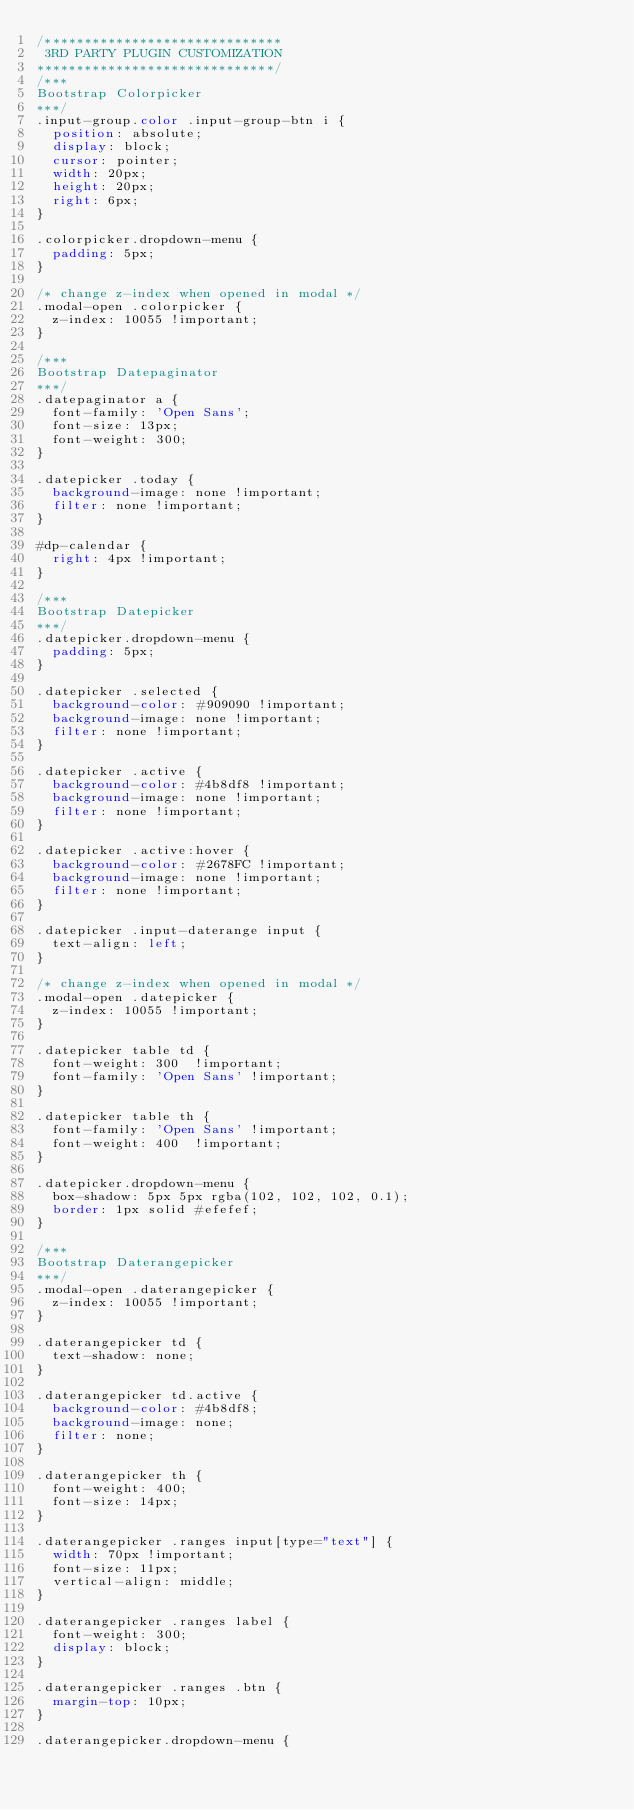Convert code to text. <code><loc_0><loc_0><loc_500><loc_500><_CSS_>/******************************
 3RD PARTY PLUGIN CUSTOMIZATION 
******************************/
/***
Bootstrap Colorpicker
***/
.input-group.color .input-group-btn i {
  position: absolute;
  display: block;
  cursor: pointer;
  width: 20px;
  height: 20px;
  right: 6px;
}

.colorpicker.dropdown-menu {
  padding: 5px;
}

/* change z-index when opened in modal */
.modal-open .colorpicker {
  z-index: 10055 !important;
}

/***
Bootstrap Datepaginator
***/
.datepaginator a {
  font-family: 'Open Sans';
  font-size: 13px;
  font-weight: 300;
}

.datepicker .today {
  background-image: none !important;
  filter: none !important;
}

#dp-calendar {
  right: 4px !important;
}

/***
Bootstrap Datepicker
***/
.datepicker.dropdown-menu {
  padding: 5px;
}

.datepicker .selected {
  background-color: #909090 !important;
  background-image: none !important;
  filter: none !important;
}

.datepicker .active {
  background-color: #4b8df8 !important;
  background-image: none !important;
  filter: none !important;
}

.datepicker .active:hover {
  background-color: #2678FC !important;
  background-image: none !important;
  filter: none !important;
}

.datepicker .input-daterange input {
  text-align: left;
}

/* change z-index when opened in modal */
.modal-open .datepicker {
  z-index: 10055 !important;
}

.datepicker table td {
  font-weight: 300  !important;
  font-family: 'Open Sans' !important;
}

.datepicker table th {
  font-family: 'Open Sans' !important;
  font-weight: 400  !important;
}

.datepicker.dropdown-menu {
  box-shadow: 5px 5px rgba(102, 102, 102, 0.1);
  border: 1px solid #efefef;
}

/***
Bootstrap Daterangepicker
***/
.modal-open .daterangepicker {
  z-index: 10055 !important;
}

.daterangepicker td {
  text-shadow: none;
}

.daterangepicker td.active {
  background-color: #4b8df8;
  background-image: none;
  filter: none;
}

.daterangepicker th {
  font-weight: 400;
  font-size: 14px;
}

.daterangepicker .ranges input[type="text"] {
  width: 70px !important;
  font-size: 11px;
  vertical-align: middle;
}

.daterangepicker .ranges label {
  font-weight: 300;
  display: block;
}

.daterangepicker .ranges .btn {
  margin-top: 10px;
}

.daterangepicker.dropdown-menu {</code> 